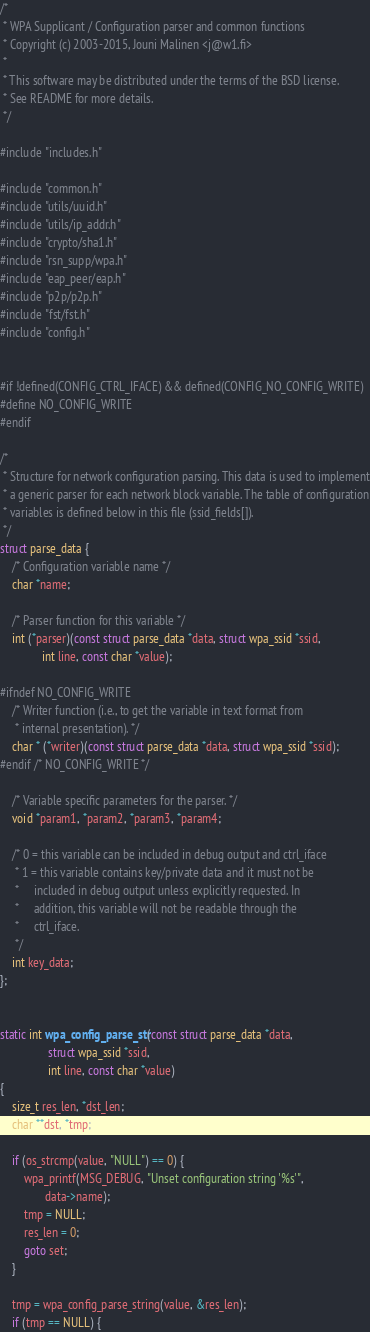<code> <loc_0><loc_0><loc_500><loc_500><_C_>/*
 * WPA Supplicant / Configuration parser and common functions
 * Copyright (c) 2003-2015, Jouni Malinen <j@w1.fi>
 *
 * This software may be distributed under the terms of the BSD license.
 * See README for more details.
 */

#include "includes.h"

#include "common.h"
#include "utils/uuid.h"
#include "utils/ip_addr.h"
#include "crypto/sha1.h"
#include "rsn_supp/wpa.h"
#include "eap_peer/eap.h"
#include "p2p/p2p.h"
#include "fst/fst.h"
#include "config.h"


#if !defined(CONFIG_CTRL_IFACE) && defined(CONFIG_NO_CONFIG_WRITE)
#define NO_CONFIG_WRITE
#endif

/*
 * Structure for network configuration parsing. This data is used to implement
 * a generic parser for each network block variable. The table of configuration
 * variables is defined below in this file (ssid_fields[]).
 */
struct parse_data {
	/* Configuration variable name */
	char *name;

	/* Parser function for this variable */
	int (*parser)(const struct parse_data *data, struct wpa_ssid *ssid,
		      int line, const char *value);

#ifndef NO_CONFIG_WRITE
	/* Writer function (i.e., to get the variable in text format from
	 * internal presentation). */
	char * (*writer)(const struct parse_data *data, struct wpa_ssid *ssid);
#endif /* NO_CONFIG_WRITE */

	/* Variable specific parameters for the parser. */
	void *param1, *param2, *param3, *param4;

	/* 0 = this variable can be included in debug output and ctrl_iface
	 * 1 = this variable contains key/private data and it must not be
	 *     included in debug output unless explicitly requested. In
	 *     addition, this variable will not be readable through the
	 *     ctrl_iface.
	 */
	int key_data;
};


static int wpa_config_parse_str(const struct parse_data *data,
				struct wpa_ssid *ssid,
				int line, const char *value)
{
	size_t res_len, *dst_len;
	char **dst, *tmp;

	if (os_strcmp(value, "NULL") == 0) {
		wpa_printf(MSG_DEBUG, "Unset configuration string '%s'",
			   data->name);
		tmp = NULL;
		res_len = 0;
		goto set;
	}

	tmp = wpa_config_parse_string(value, &res_len);
	if (tmp == NULL) {</code> 